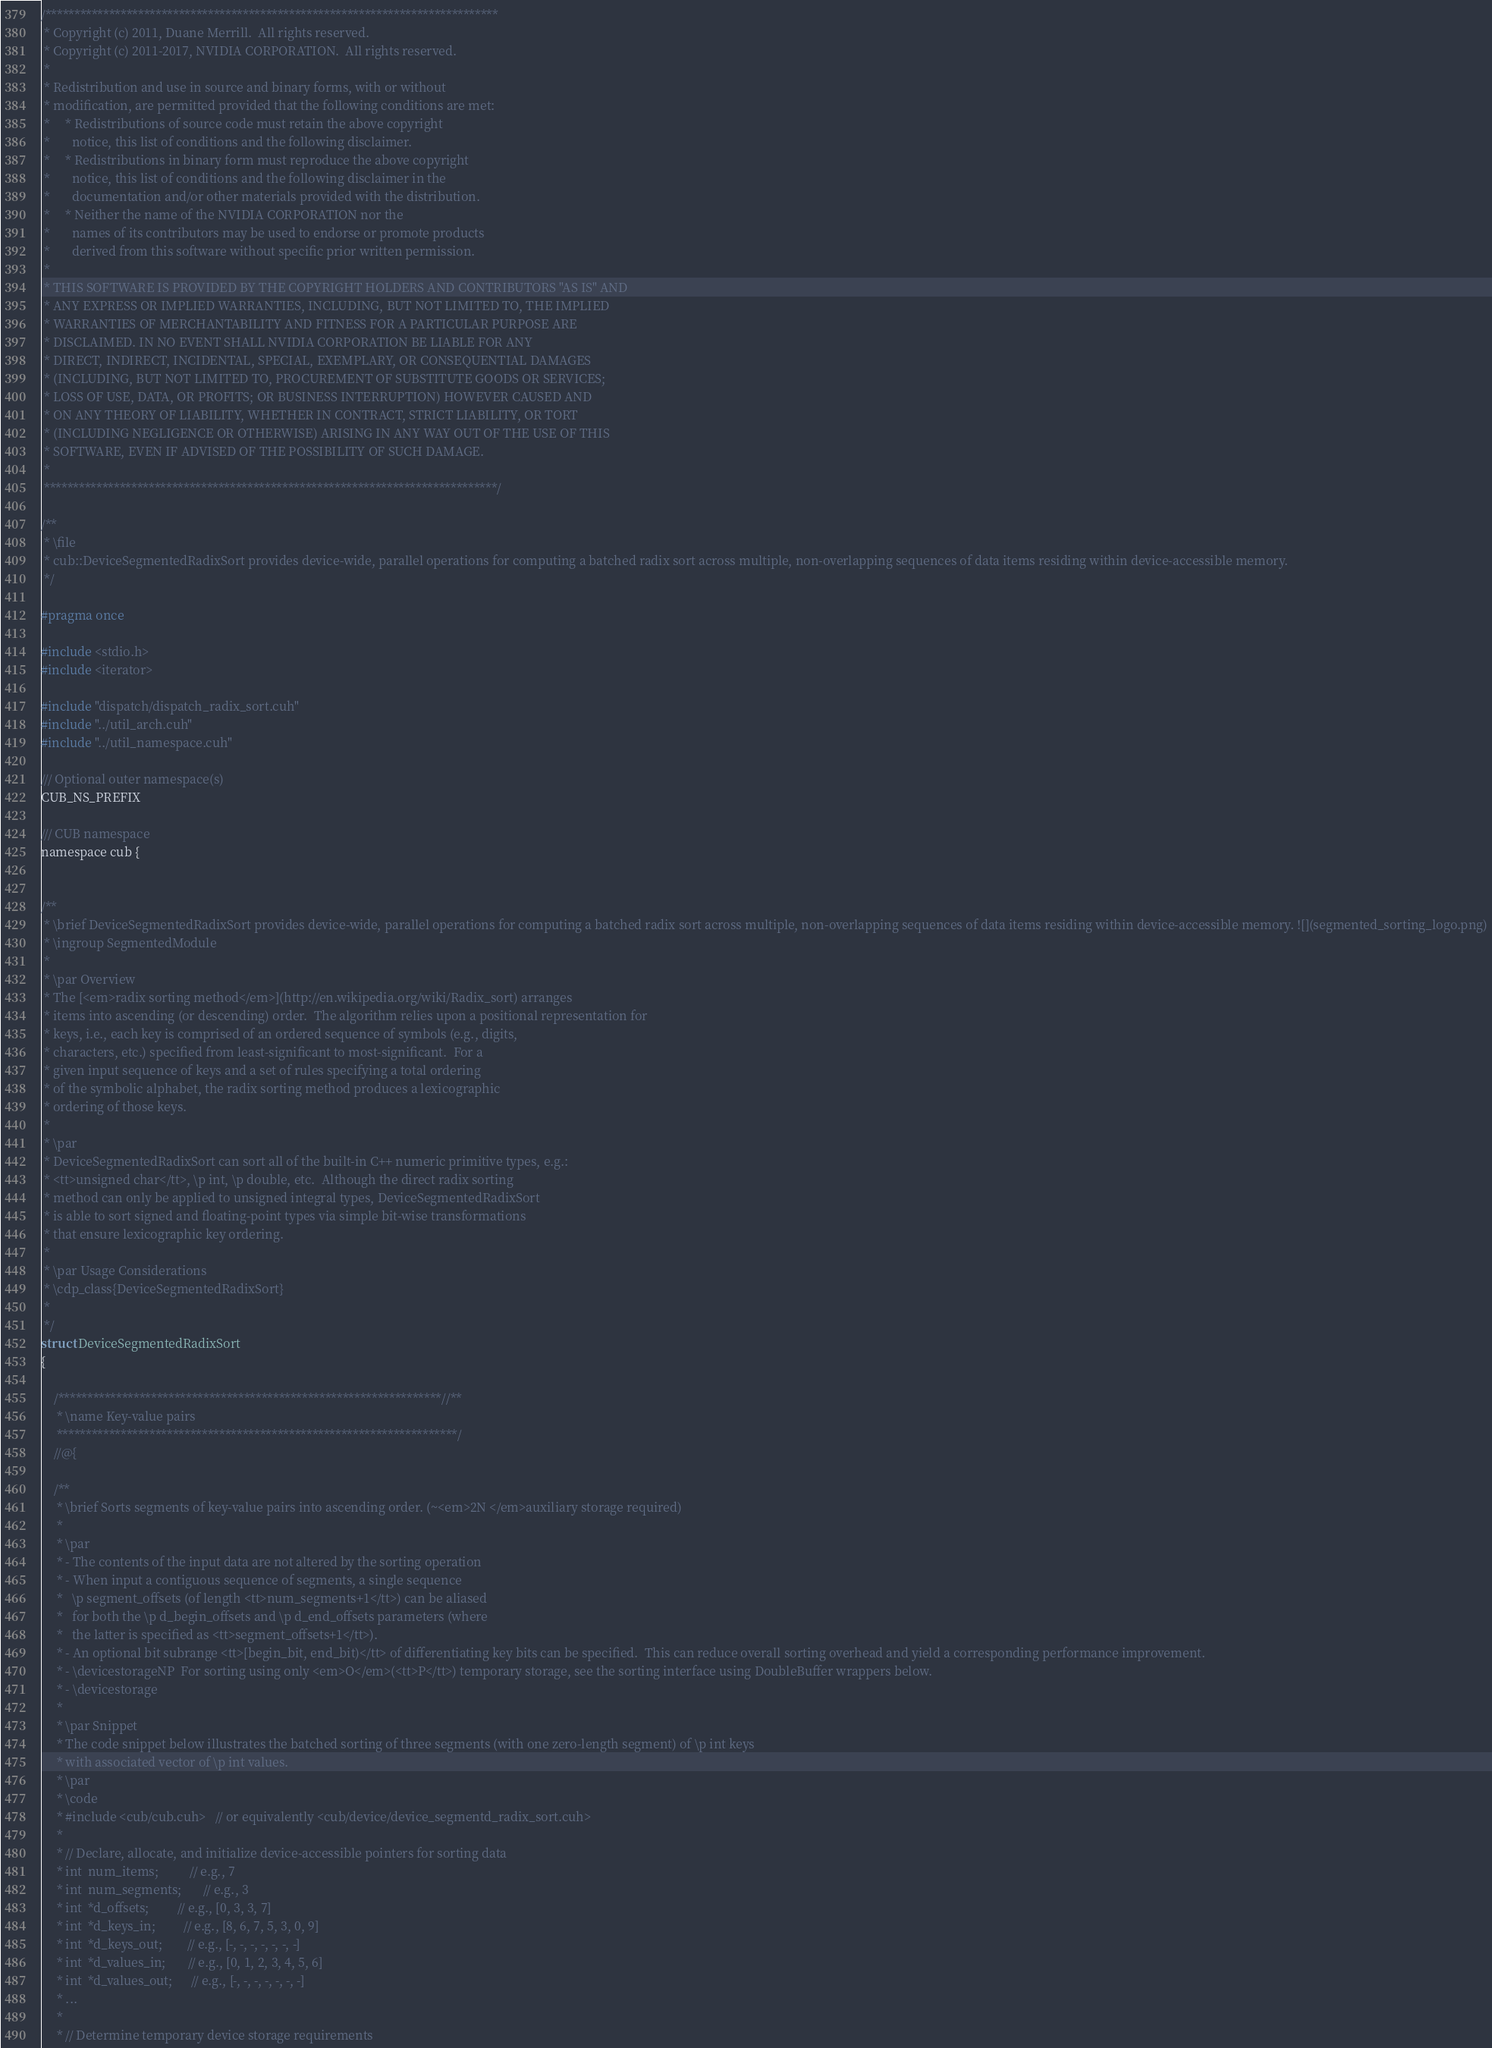Convert code to text. <code><loc_0><loc_0><loc_500><loc_500><_Cuda_>
/******************************************************************************
 * Copyright (c) 2011, Duane Merrill.  All rights reserved.
 * Copyright (c) 2011-2017, NVIDIA CORPORATION.  All rights reserved.
 *
 * Redistribution and use in source and binary forms, with or without
 * modification, are permitted provided that the following conditions are met:
 *     * Redistributions of source code must retain the above copyright
 *       notice, this list of conditions and the following disclaimer.
 *     * Redistributions in binary form must reproduce the above copyright
 *       notice, this list of conditions and the following disclaimer in the
 *       documentation and/or other materials provided with the distribution.
 *     * Neither the name of the NVIDIA CORPORATION nor the
 *       names of its contributors may be used to endorse or promote products
 *       derived from this software without specific prior written permission.
 *
 * THIS SOFTWARE IS PROVIDED BY THE COPYRIGHT HOLDERS AND CONTRIBUTORS "AS IS" AND
 * ANY EXPRESS OR IMPLIED WARRANTIES, INCLUDING, BUT NOT LIMITED TO, THE IMPLIED
 * WARRANTIES OF MERCHANTABILITY AND FITNESS FOR A PARTICULAR PURPOSE ARE
 * DISCLAIMED. IN NO EVENT SHALL NVIDIA CORPORATION BE LIABLE FOR ANY
 * DIRECT, INDIRECT, INCIDENTAL, SPECIAL, EXEMPLARY, OR CONSEQUENTIAL DAMAGES
 * (INCLUDING, BUT NOT LIMITED TO, PROCUREMENT OF SUBSTITUTE GOODS OR SERVICES;
 * LOSS OF USE, DATA, OR PROFITS; OR BUSINESS INTERRUPTION) HOWEVER CAUSED AND
 * ON ANY THEORY OF LIABILITY, WHETHER IN CONTRACT, STRICT LIABILITY, OR TORT
 * (INCLUDING NEGLIGENCE OR OTHERWISE) ARISING IN ANY WAY OUT OF THE USE OF THIS
 * SOFTWARE, EVEN IF ADVISED OF THE POSSIBILITY OF SUCH DAMAGE.
 *
 ******************************************************************************/

/**
 * \file
 * cub::DeviceSegmentedRadixSort provides device-wide, parallel operations for computing a batched radix sort across multiple, non-overlapping sequences of data items residing within device-accessible memory.
 */

#pragma once

#include <stdio.h>
#include <iterator>

#include "dispatch/dispatch_radix_sort.cuh"
#include "../util_arch.cuh"
#include "../util_namespace.cuh"

/// Optional outer namespace(s)
CUB_NS_PREFIX

/// CUB namespace
namespace cub {


/**
 * \brief DeviceSegmentedRadixSort provides device-wide, parallel operations for computing a batched radix sort across multiple, non-overlapping sequences of data items residing within device-accessible memory. ![](segmented_sorting_logo.png)
 * \ingroup SegmentedModule
 *
 * \par Overview
 * The [<em>radix sorting method</em>](http://en.wikipedia.org/wiki/Radix_sort) arranges
 * items into ascending (or descending) order.  The algorithm relies upon a positional representation for
 * keys, i.e., each key is comprised of an ordered sequence of symbols (e.g., digits,
 * characters, etc.) specified from least-significant to most-significant.  For a
 * given input sequence of keys and a set of rules specifying a total ordering
 * of the symbolic alphabet, the radix sorting method produces a lexicographic
 * ordering of those keys.
 *
 * \par
 * DeviceSegmentedRadixSort can sort all of the built-in C++ numeric primitive types, e.g.:
 * <tt>unsigned char</tt>, \p int, \p double, etc.  Although the direct radix sorting
 * method can only be applied to unsigned integral types, DeviceSegmentedRadixSort
 * is able to sort signed and floating-point types via simple bit-wise transformations
 * that ensure lexicographic key ordering.
 *
 * \par Usage Considerations
 * \cdp_class{DeviceSegmentedRadixSort}
 *
 */
struct DeviceSegmentedRadixSort
{

    /******************************************************************//**
     * \name Key-value pairs
     *********************************************************************/
    //@{

    /**
     * \brief Sorts segments of key-value pairs into ascending order. (~<em>2N </em>auxiliary storage required)
     *
     * \par
     * - The contents of the input data are not altered by the sorting operation
     * - When input a contiguous sequence of segments, a single sequence
     *   \p segment_offsets (of length <tt>num_segments+1</tt>) can be aliased
     *   for both the \p d_begin_offsets and \p d_end_offsets parameters (where
     *   the latter is specified as <tt>segment_offsets+1</tt>).
     * - An optional bit subrange <tt>[begin_bit, end_bit)</tt> of differentiating key bits can be specified.  This can reduce overall sorting overhead and yield a corresponding performance improvement.
     * - \devicestorageNP  For sorting using only <em>O</em>(<tt>P</tt>) temporary storage, see the sorting interface using DoubleBuffer wrappers below.
     * - \devicestorage
     *
     * \par Snippet
     * The code snippet below illustrates the batched sorting of three segments (with one zero-length segment) of \p int keys
     * with associated vector of \p int values.
     * \par
     * \code
     * #include <cub/cub.cuh>   // or equivalently <cub/device/device_segmentd_radix_sort.cuh>
     *
     * // Declare, allocate, and initialize device-accessible pointers for sorting data
     * int  num_items;          // e.g., 7
     * int  num_segments;       // e.g., 3
     * int  *d_offsets;         // e.g., [0, 3, 3, 7]
     * int  *d_keys_in;         // e.g., [8, 6, 7, 5, 3, 0, 9]
     * int  *d_keys_out;        // e.g., [-, -, -, -, -, -, -]
     * int  *d_values_in;       // e.g., [0, 1, 2, 3, 4, 5, 6]
     * int  *d_values_out;      // e.g., [-, -, -, -, -, -, -]
     * ...
     *
     * // Determine temporary device storage requirements</code> 